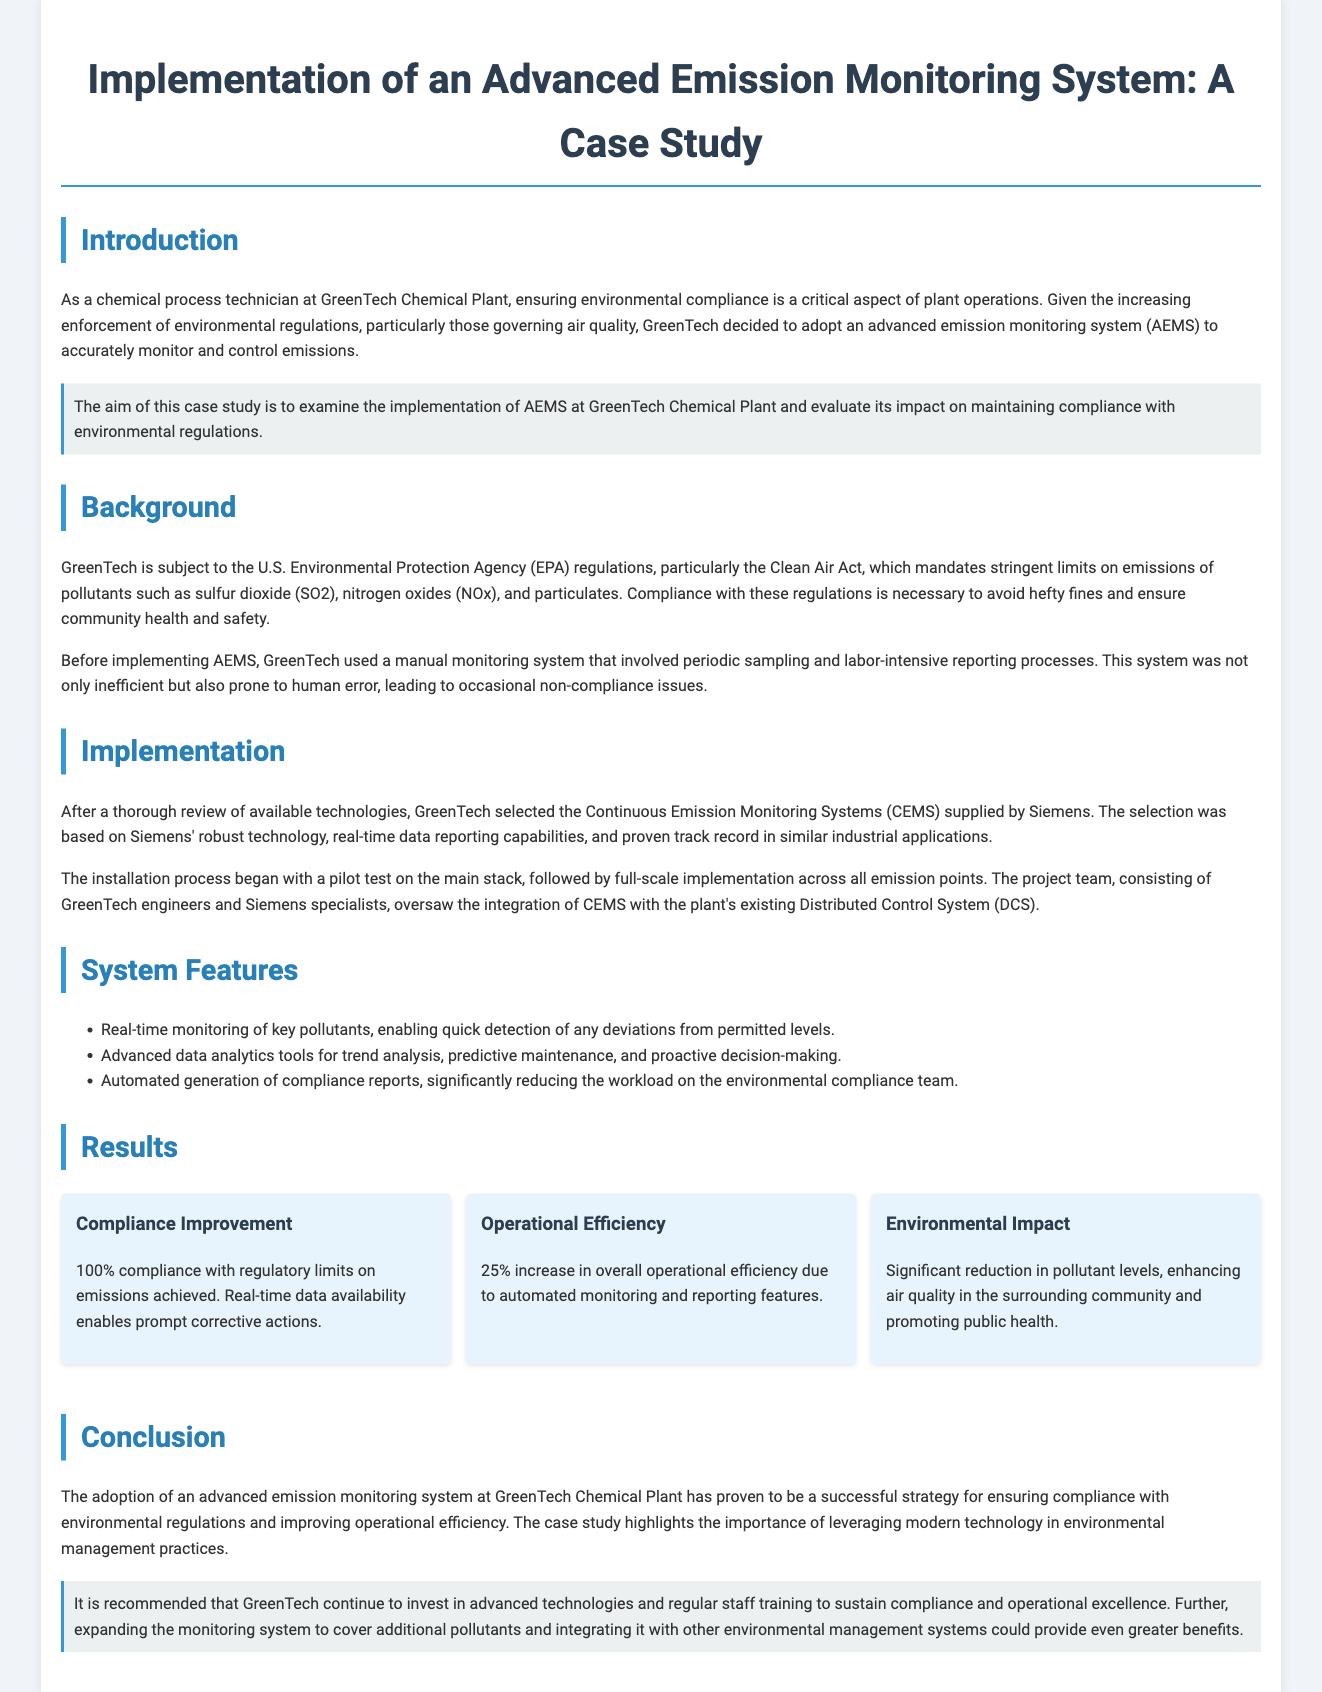what is the main objective of the case study? The case study examines the implementation of AEMS at GreenTech Chemical Plant and evaluates its impact on maintaining compliance with environmental regulations.
Answer: implementation of AEMS at GreenTech Chemical Plant what technology was selected for monitoring emissions? The document states that GreenTech selected the Continuous Emission Monitoring Systems supplied by Siemens for monitoring emissions.
Answer: Continuous Emission Monitoring Systems which pollutants are specifically mentioned in the case study? The case study specifically mentions sulfur dioxide (SO2), nitrogen oxides (NOx), and particulates as pollutants that are regulated.
Answer: sulfur dioxide, nitrogen oxides, particulates how much did operational efficiency increase as a result of the system? According to the results, the case study reports a 25% increase in overall operational efficiency due to the AEMS.
Answer: 25% what is the significance of real-time monitoring in the context of the document? Real-time monitoring allows for quick detection of deviations from permitted levels, enabling prompt corrective actions to maintain compliance.
Answer: quick detection of deviations how many compliance reports are generated automatically by the AEMS? The case study highlights the automated generation of compliance reports but does not specify a number; thus, the answer refers to the automation itself.
Answer: automated generation what is recommended for GreenTech to maintain operational excellence? The case study recommends that GreenTech continue to invest in advanced technologies and regular staff training.
Answer: invest in advanced technologies and regular staff training what was the compliance rate after implementation of the AEMS? The implementation of AEMS achieved a 100% compliance rate with regulatory limits on emissions.
Answer: 100% compliance what benefit did the surrounding community experience due to the emissions monitoring system? The case study mentions a significant reduction in pollutant levels, enhancing air quality and promoting public health in the surrounding community.
Answer: enhancement of air quality 